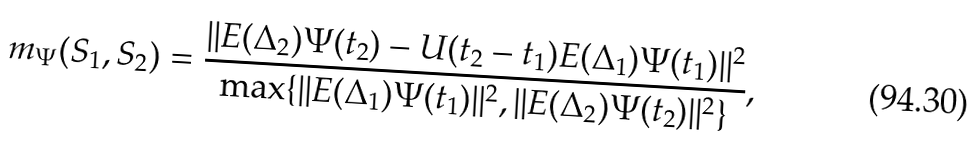Convert formula to latex. <formula><loc_0><loc_0><loc_500><loc_500>m _ { \Psi } ( S _ { 1 } , S _ { 2 } ) = \frac { | | E ( \Delta _ { 2 } ) \Psi ( t _ { 2 } ) - U ( t _ { 2 } - t _ { 1 } ) E ( \Delta _ { 1 } ) \Psi ( t _ { 1 } ) | | ^ { 2 } } { \max \{ | | E ( \Delta _ { 1 } ) \Psi ( t _ { 1 } ) | | ^ { 2 } , | | E ( \Delta _ { 2 } ) \Psi ( t _ { 2 } ) | | ^ { 2 } \} } ,</formula> 